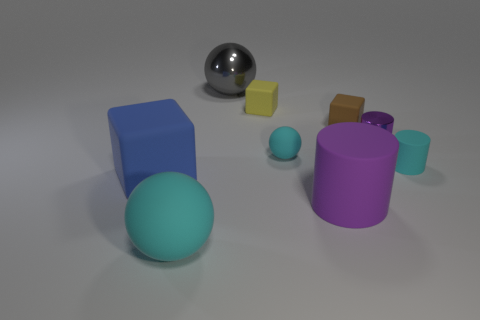What number of other objects are there of the same color as the small ball?
Your answer should be compact. 2. Is the color of the tiny rubber ball the same as the big sphere that is in front of the small cyan matte ball?
Offer a terse response. Yes. What is the material of the tiny ball that is the same color as the tiny matte cylinder?
Offer a terse response. Rubber. Are there any blue blocks made of the same material as the large cylinder?
Ensure brevity in your answer.  Yes. The other ball that is the same color as the tiny ball is what size?
Your answer should be compact. Large. Is the size of the cyan rubber thing left of the small cyan matte ball the same as the purple object in front of the large blue cube?
Offer a very short reply. Yes. There is a cyan sphere on the right side of the large cyan sphere; how big is it?
Provide a succinct answer. Small. Is there another rubber sphere that has the same color as the small matte ball?
Offer a terse response. Yes. Are there any purple cylinders in front of the tiny cyan thing left of the small cyan cylinder?
Your response must be concise. Yes. Do the blue thing and the cube that is right of the large matte cylinder have the same size?
Ensure brevity in your answer.  No. 